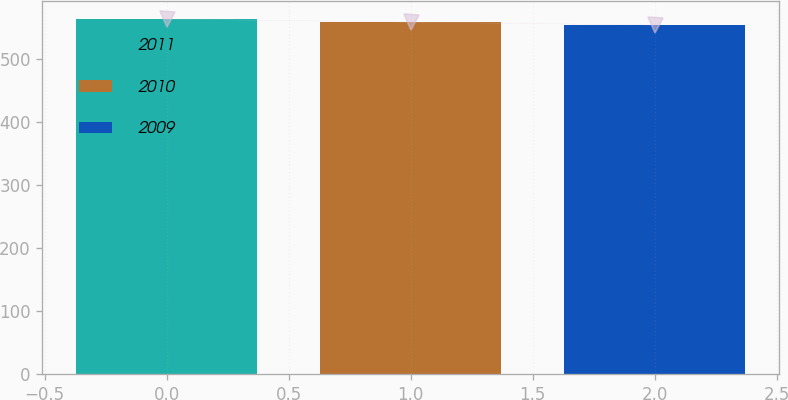Convert chart to OTSL. <chart><loc_0><loc_0><loc_500><loc_500><bar_chart><fcel>2011<fcel>2010<fcel>2009<nl><fcel>563.4<fcel>558.6<fcel>554<nl></chart> 